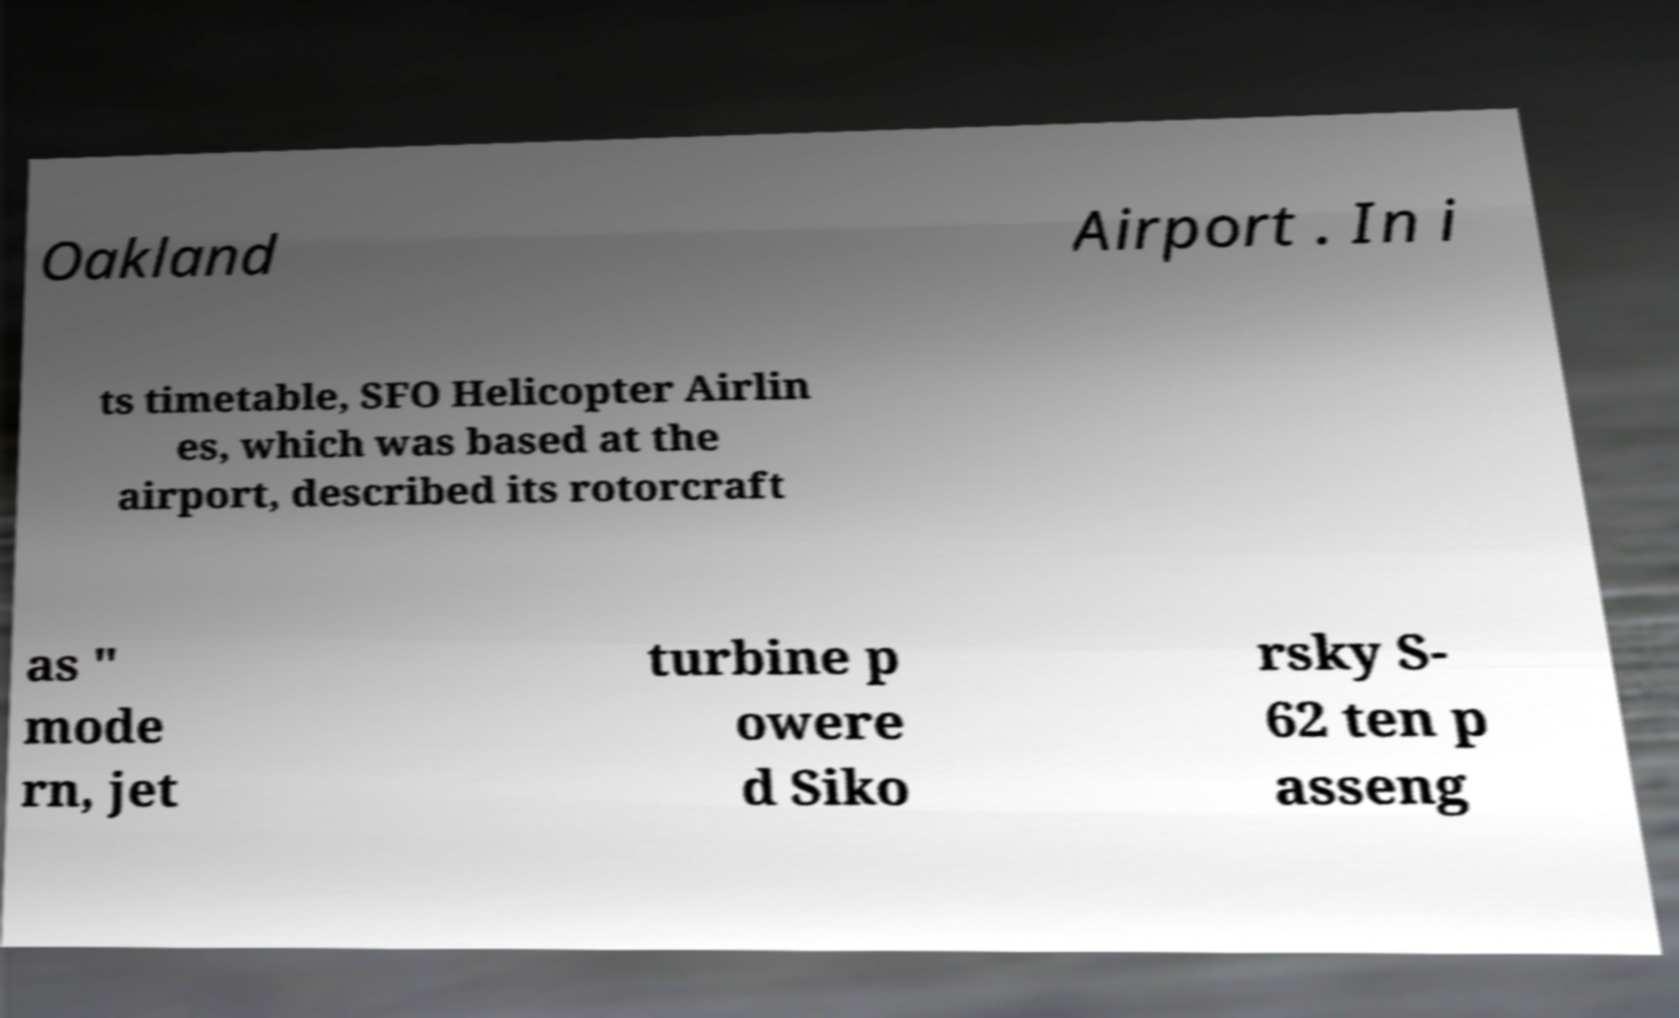Could you extract and type out the text from this image? Oakland Airport . In i ts timetable, SFO Helicopter Airlin es, which was based at the airport, described its rotorcraft as " mode rn, jet turbine p owere d Siko rsky S- 62 ten p asseng 